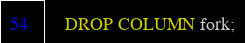Convert code to text. <code><loc_0><loc_0><loc_500><loc_500><_SQL_>    DROP COLUMN fork;</code> 